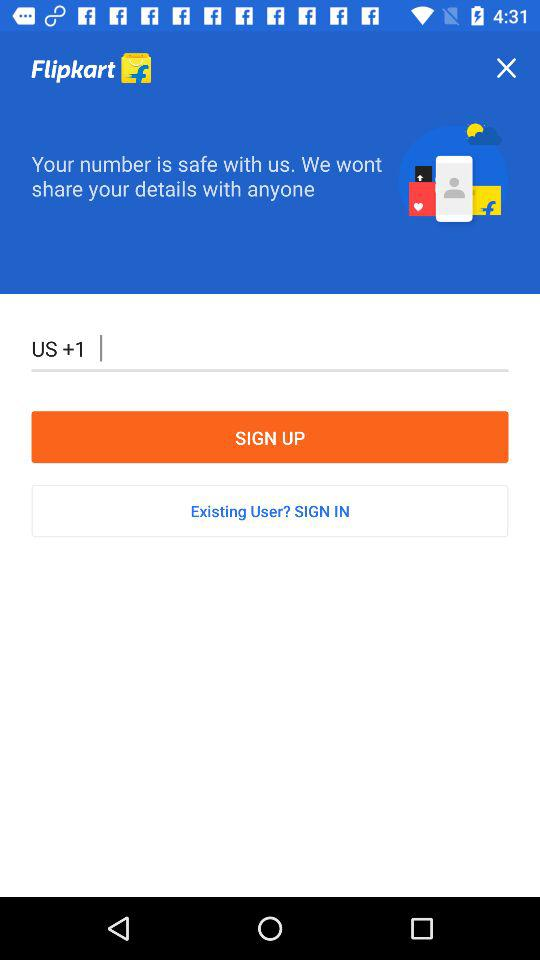What is the app title? The app title is "Flipkart". 